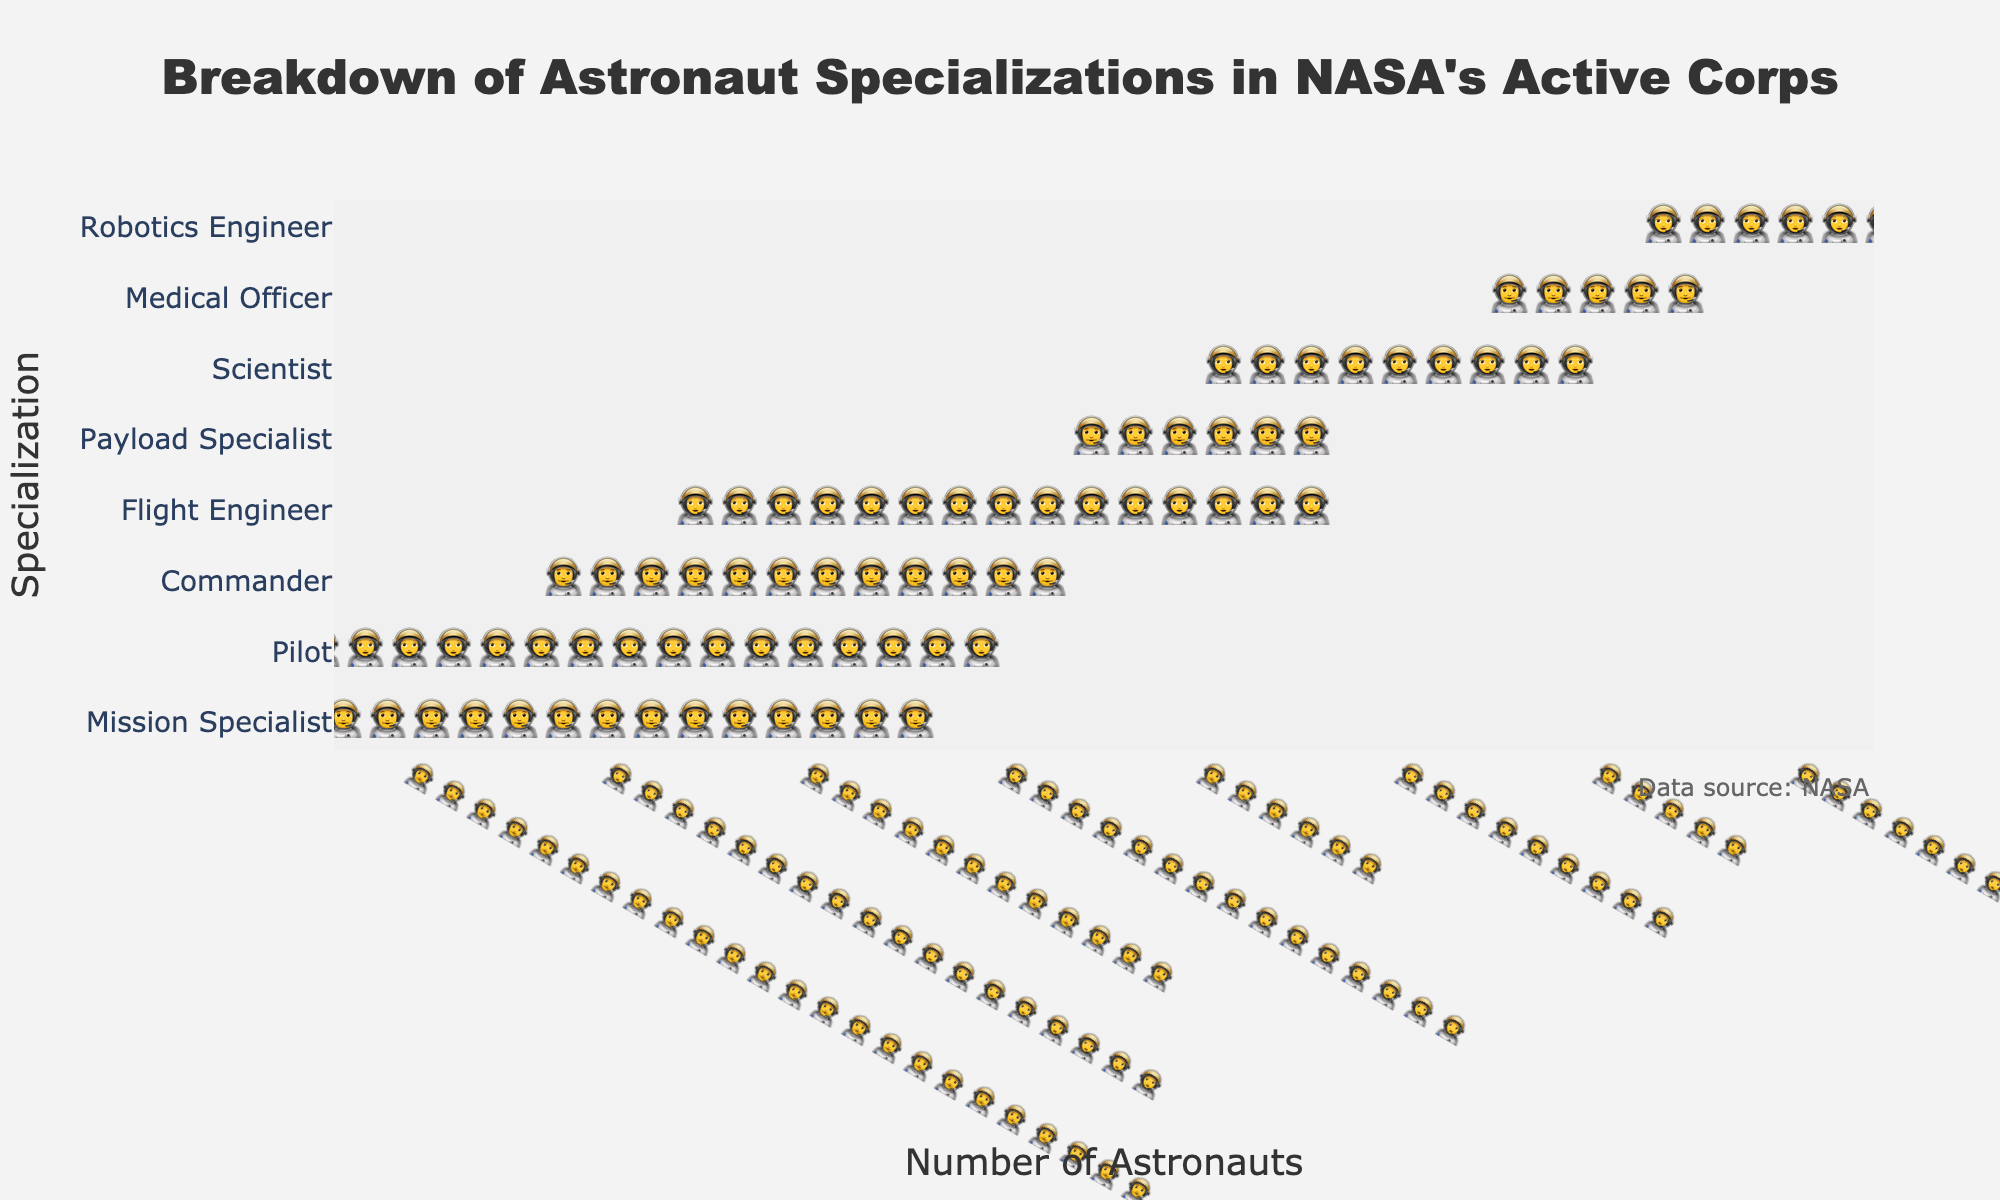Which specialization has the highest number of astronauts? The figure shows the count of astronauts for each specialization using icons. By observation, 'Mission Specialist' has the most icons.
Answer: Mission Specialist What is the total number of astronauts depicted in the figure? Sum up the counts of all specializations: 24+18+12+15+6+9+5+7 = 96.
Answer: 96 Which specialization has fewer astronauts, 'Scientist' or 'Robotics Engineer'? Compare the counts for 'Scientist' (9) and 'Robotics Engineer' (7).
Answer: Robotics Engineer How many more astronauts are 'Mission Specialists' compared to 'Medical Officers'? Subtract the number of 'Medical Officers' (5) from 'Mission Specialists' (24): 24 - 5 = 19.
Answer: 19 Are there more 'Pilots' or 'Flight Engineers' in NASA's active corps? Compare the counts for 'Pilots' (18) and 'Flight Engineers' (15).
Answer: Pilots What's the difference in the number of 'Commanders' and 'Payload Specialists'? Subtract the count of 'Payload Specialists' (6) from 'Commanders' (12): 12 - 6 = 6.
Answer: 6 What is the combined total of 'Pilots' and 'Commanders'? Add the counts of 'Pilots' (18) and 'Commanders' (12): 18 + 12 = 30.
Answer: 30 Which specialization is represented by the fewest astronauts? The figure shows 'Medical Officer' with the fewest icons (5).
Answer: Medical Officer Among all specializations, how many have a count greater than 10? Identify specializations with counts greater than 10: 'Mission Specialist' (24), 'Pilot' (18), 'Commander' (12), and 'Flight Engineer' (15). There are 4 of them.
Answer: 4 Which specializations have between 5 and 10 astronauts? Identify specializations with counts in the range 5 to 10: 'Payload Specialist' (6), 'Scientist' (9), 'Medical Officer' (5), and 'Robotics Engineer' (7).
Answer: Payload Specialist, Scientist, Medical Officer, Robotics Engineer 